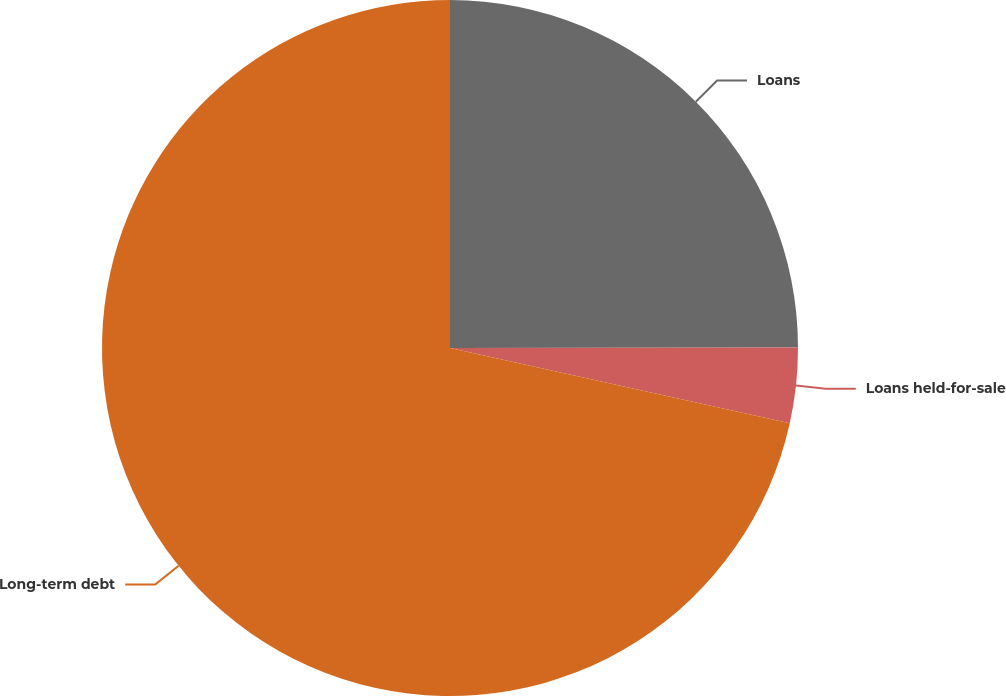Convert chart to OTSL. <chart><loc_0><loc_0><loc_500><loc_500><pie_chart><fcel>Loans<fcel>Loans held-for-sale<fcel>Long-term debt<nl><fcel>24.97%<fcel>3.5%<fcel>71.52%<nl></chart> 